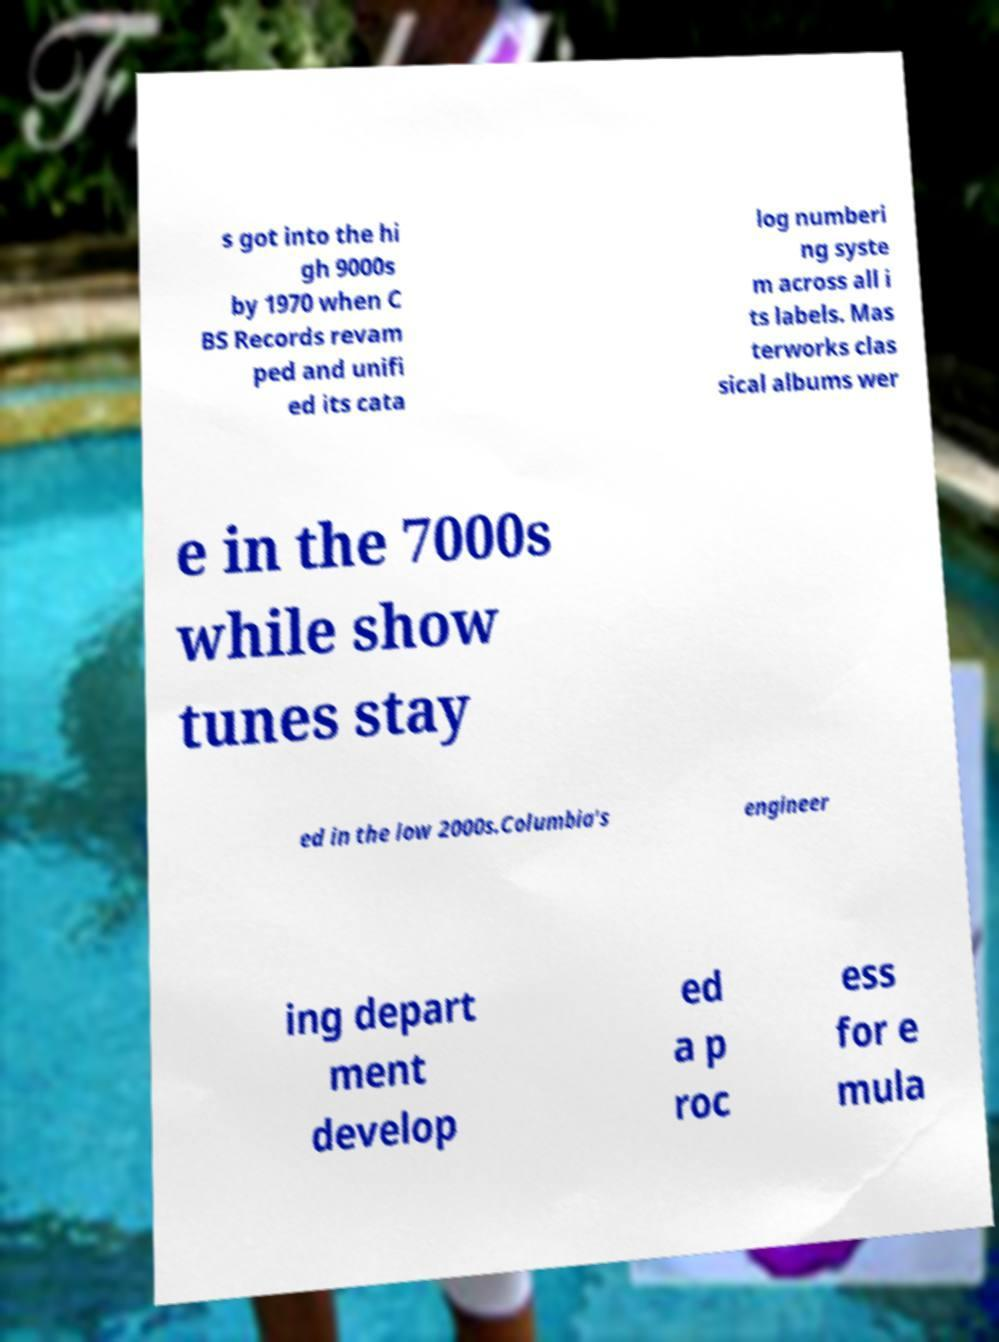There's text embedded in this image that I need extracted. Can you transcribe it verbatim? s got into the hi gh 9000s by 1970 when C BS Records revam ped and unifi ed its cata log numberi ng syste m across all i ts labels. Mas terworks clas sical albums wer e in the 7000s while show tunes stay ed in the low 2000s.Columbia's engineer ing depart ment develop ed a p roc ess for e mula 